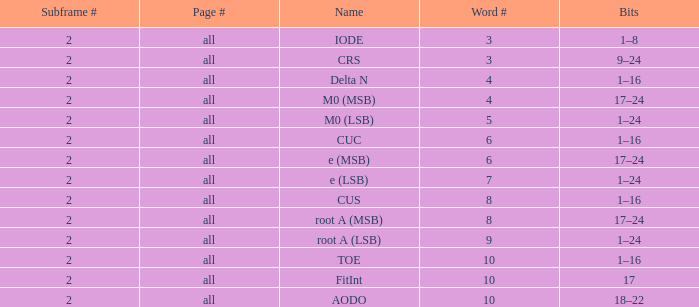What is the page count and word count greater than 5 with Bits of 18–22? All. 